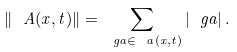<formula> <loc_0><loc_0><loc_500><loc_500>\| \ A ( x , t ) \| = \sum _ { \ g a \in \ a ( x , t ) } | \ g a | \, .</formula> 